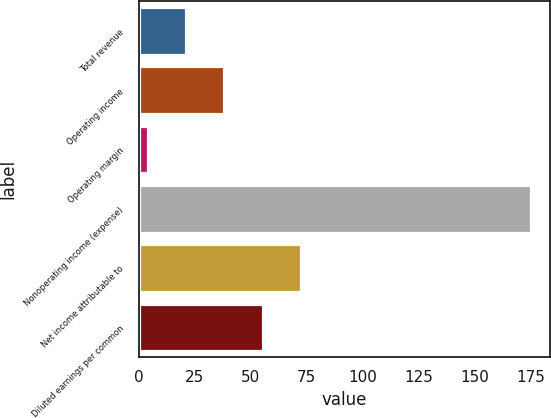Convert chart to OTSL. <chart><loc_0><loc_0><loc_500><loc_500><bar_chart><fcel>Total revenue<fcel>Operating income<fcel>Operating margin<fcel>Nonoperating income (expense)<fcel>Net income attributable to<fcel>Diluted earnings per common<nl><fcel>21.1<fcel>38.2<fcel>4<fcel>175<fcel>72.4<fcel>55.3<nl></chart> 